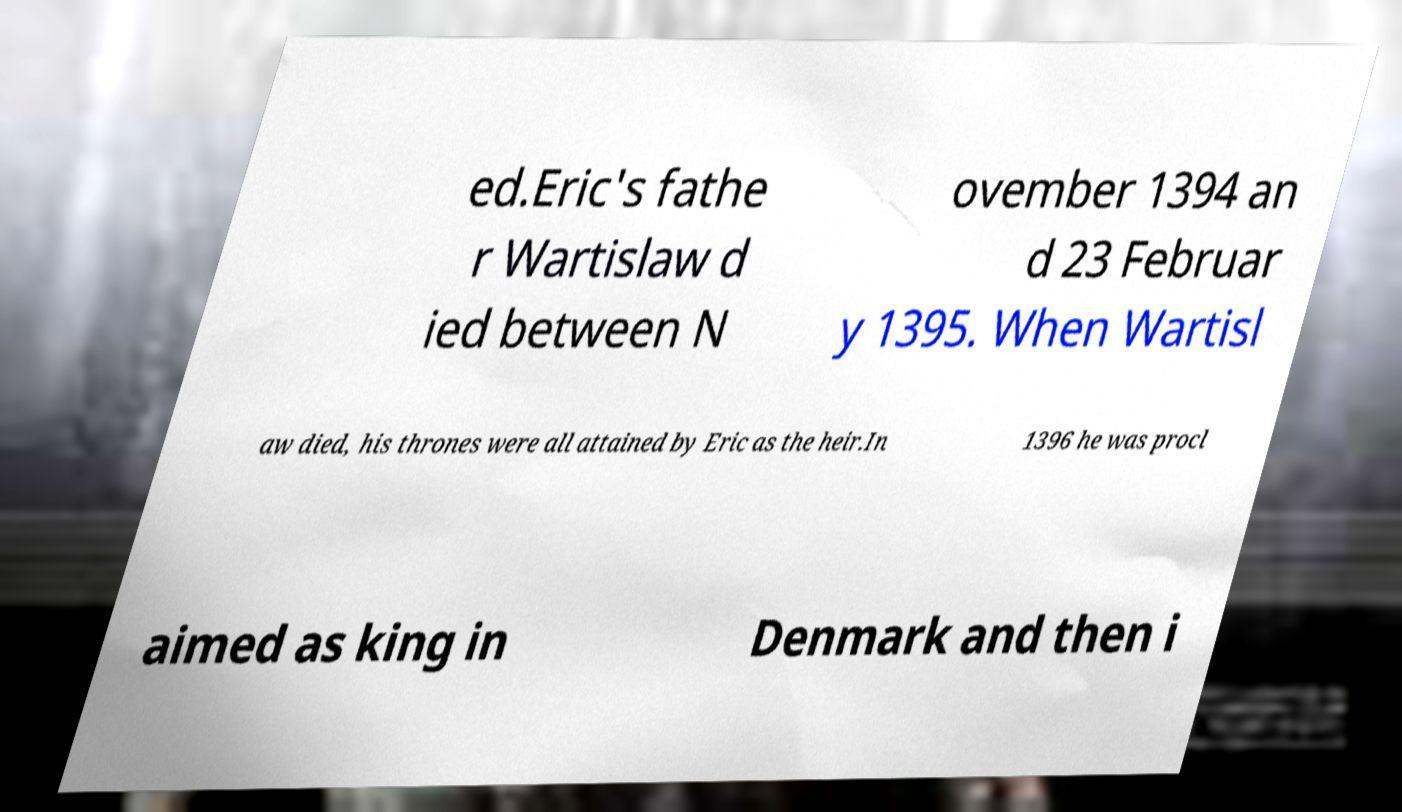Please identify and transcribe the text found in this image. ed.Eric's fathe r Wartislaw d ied between N ovember 1394 an d 23 Februar y 1395. When Wartisl aw died, his thrones were all attained by Eric as the heir.In 1396 he was procl aimed as king in Denmark and then i 